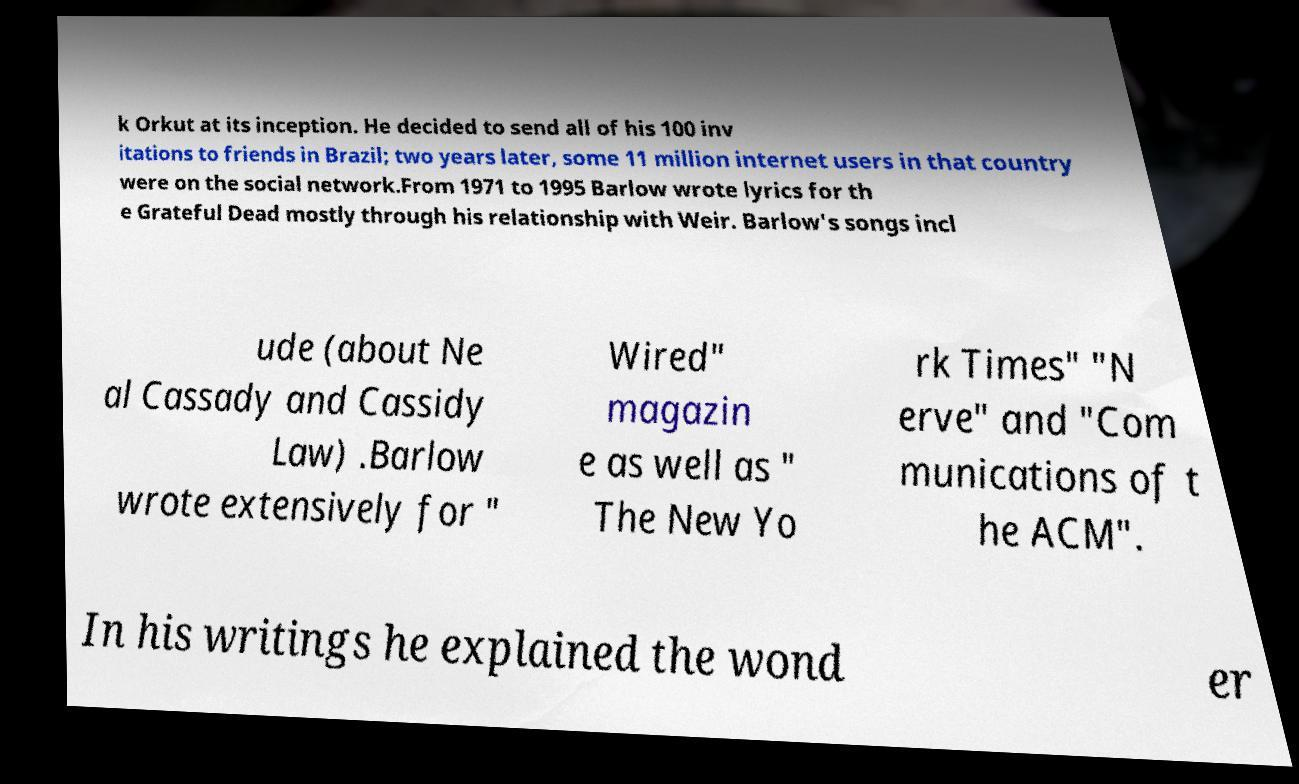Can you accurately transcribe the text from the provided image for me? k Orkut at its inception. He decided to send all of his 100 inv itations to friends in Brazil; two years later, some 11 million internet users in that country were on the social network.From 1971 to 1995 Barlow wrote lyrics for th e Grateful Dead mostly through his relationship with Weir. Barlow's songs incl ude (about Ne al Cassady and Cassidy Law) .Barlow wrote extensively for " Wired" magazin e as well as " The New Yo rk Times" "N erve" and "Com munications of t he ACM". In his writings he explained the wond er 